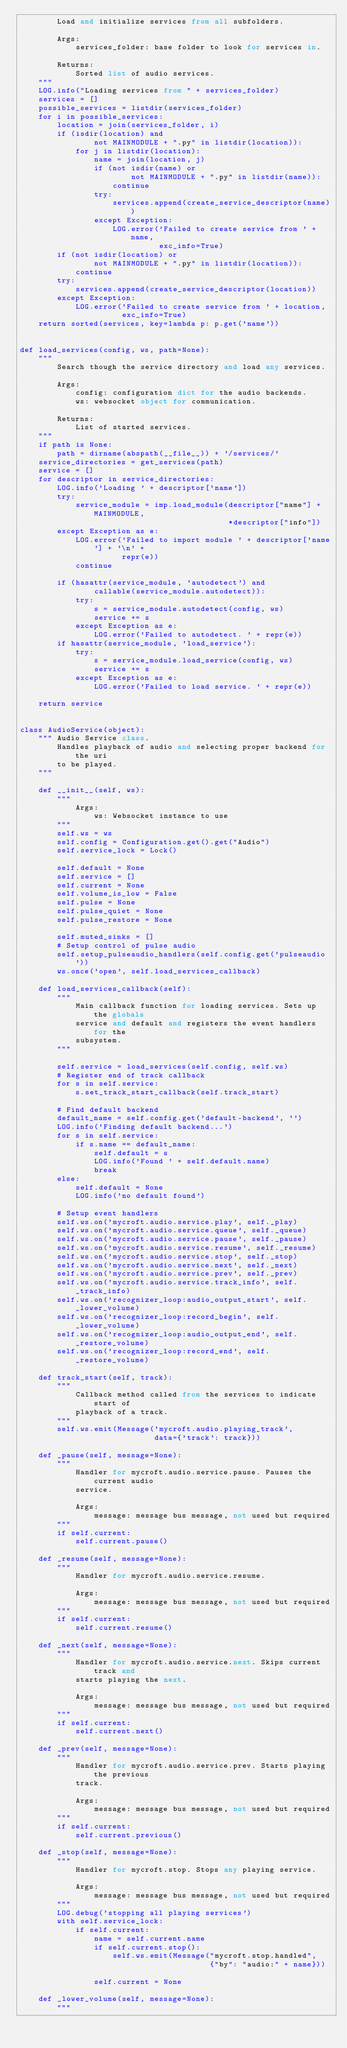<code> <loc_0><loc_0><loc_500><loc_500><_Python_>        Load and initialize services from all subfolders.

        Args:
            services_folder: base folder to look for services in.

        Returns:
            Sorted list of audio services.
    """
    LOG.info("Loading services from " + services_folder)
    services = []
    possible_services = listdir(services_folder)
    for i in possible_services:
        location = join(services_folder, i)
        if (isdir(location) and
                not MAINMODULE + ".py" in listdir(location)):
            for j in listdir(location):
                name = join(location, j)
                if (not isdir(name) or
                        not MAINMODULE + ".py" in listdir(name)):
                    continue
                try:
                    services.append(create_service_descriptor(name))
                except Exception:
                    LOG.error('Failed to create service from ' + name,
                              exc_info=True)
        if (not isdir(location) or
                not MAINMODULE + ".py" in listdir(location)):
            continue
        try:
            services.append(create_service_descriptor(location))
        except Exception:
            LOG.error('Failed to create service from ' + location,
                      exc_info=True)
    return sorted(services, key=lambda p: p.get('name'))


def load_services(config, ws, path=None):
    """
        Search though the service directory and load any services.

        Args:
            config: configuration dict for the audio backends.
            ws: websocket object for communication.

        Returns:
            List of started services.
    """
    if path is None:
        path = dirname(abspath(__file__)) + '/services/'
    service_directories = get_services(path)
    service = []
    for descriptor in service_directories:
        LOG.info('Loading ' + descriptor['name'])
        try:
            service_module = imp.load_module(descriptor["name"] + MAINMODULE,
                                             *descriptor["info"])
        except Exception as e:
            LOG.error('Failed to import module ' + descriptor['name'] + '\n' +
                      repr(e))
            continue

        if (hasattr(service_module, 'autodetect') and
                callable(service_module.autodetect)):
            try:
                s = service_module.autodetect(config, ws)
                service += s
            except Exception as e:
                LOG.error('Failed to autodetect. ' + repr(e))
        if hasattr(service_module, 'load_service'):
            try:
                s = service_module.load_service(config, ws)
                service += s
            except Exception as e:
                LOG.error('Failed to load service. ' + repr(e))

    return service


class AudioService(object):
    """ Audio Service class.
        Handles playback of audio and selecting proper backend for the uri
        to be played.
    """

    def __init__(self, ws):
        """
            Args:
                ws: Websocket instance to use
        """
        self.ws = ws
        self.config = Configuration.get().get("Audio")
        self.service_lock = Lock()

        self.default = None
        self.service = []
        self.current = None
        self.volume_is_low = False
        self.pulse = None
        self.pulse_quiet = None
        self.pulse_restore = None

        self.muted_sinks = []
        # Setup control of pulse audio
        self.setup_pulseaudio_handlers(self.config.get('pulseaudio'))
        ws.once('open', self.load_services_callback)

    def load_services_callback(self):
        """
            Main callback function for loading services. Sets up the globals
            service and default and registers the event handlers for the
            subsystem.
        """

        self.service = load_services(self.config, self.ws)
        # Register end of track callback
        for s in self.service:
            s.set_track_start_callback(self.track_start)

        # Find default backend
        default_name = self.config.get('default-backend', '')
        LOG.info('Finding default backend...')
        for s in self.service:
            if s.name == default_name:
                self.default = s
                LOG.info('Found ' + self.default.name)
                break
        else:
            self.default = None
            LOG.info('no default found')

        # Setup event handlers
        self.ws.on('mycroft.audio.service.play', self._play)
        self.ws.on('mycroft.audio.service.queue', self._queue)
        self.ws.on('mycroft.audio.service.pause', self._pause)
        self.ws.on('mycroft.audio.service.resume', self._resume)
        self.ws.on('mycroft.audio.service.stop', self._stop)
        self.ws.on('mycroft.audio.service.next', self._next)
        self.ws.on('mycroft.audio.service.prev', self._prev)
        self.ws.on('mycroft.audio.service.track_info', self._track_info)
        self.ws.on('recognizer_loop:audio_output_start', self._lower_volume)
        self.ws.on('recognizer_loop:record_begin', self._lower_volume)
        self.ws.on('recognizer_loop:audio_output_end', self._restore_volume)
        self.ws.on('recognizer_loop:record_end', self._restore_volume)

    def track_start(self, track):
        """
            Callback method called from the services to indicate start of
            playback of a track.
        """
        self.ws.emit(Message('mycroft.audio.playing_track',
                             data={'track': track}))

    def _pause(self, message=None):
        """
            Handler for mycroft.audio.service.pause. Pauses the current audio
            service.

            Args:
                message: message bus message, not used but required
        """
        if self.current:
            self.current.pause()

    def _resume(self, message=None):
        """
            Handler for mycroft.audio.service.resume.

            Args:
                message: message bus message, not used but required
        """
        if self.current:
            self.current.resume()

    def _next(self, message=None):
        """
            Handler for mycroft.audio.service.next. Skips current track and
            starts playing the next.

            Args:
                message: message bus message, not used but required
        """
        if self.current:
            self.current.next()

    def _prev(self, message=None):
        """
            Handler for mycroft.audio.service.prev. Starts playing the previous
            track.

            Args:
                message: message bus message, not used but required
        """
        if self.current:
            self.current.previous()

    def _stop(self, message=None):
        """
            Handler for mycroft.stop. Stops any playing service.

            Args:
                message: message bus message, not used but required
        """
        LOG.debug('stopping all playing services')
        with self.service_lock:
            if self.current:
                name = self.current.name
                if self.current.stop():
                    self.ws.emit(Message("mycroft.stop.handled",
                                         {"by": "audio:" + name}))

                self.current = None

    def _lower_volume(self, message=None):
        """</code> 